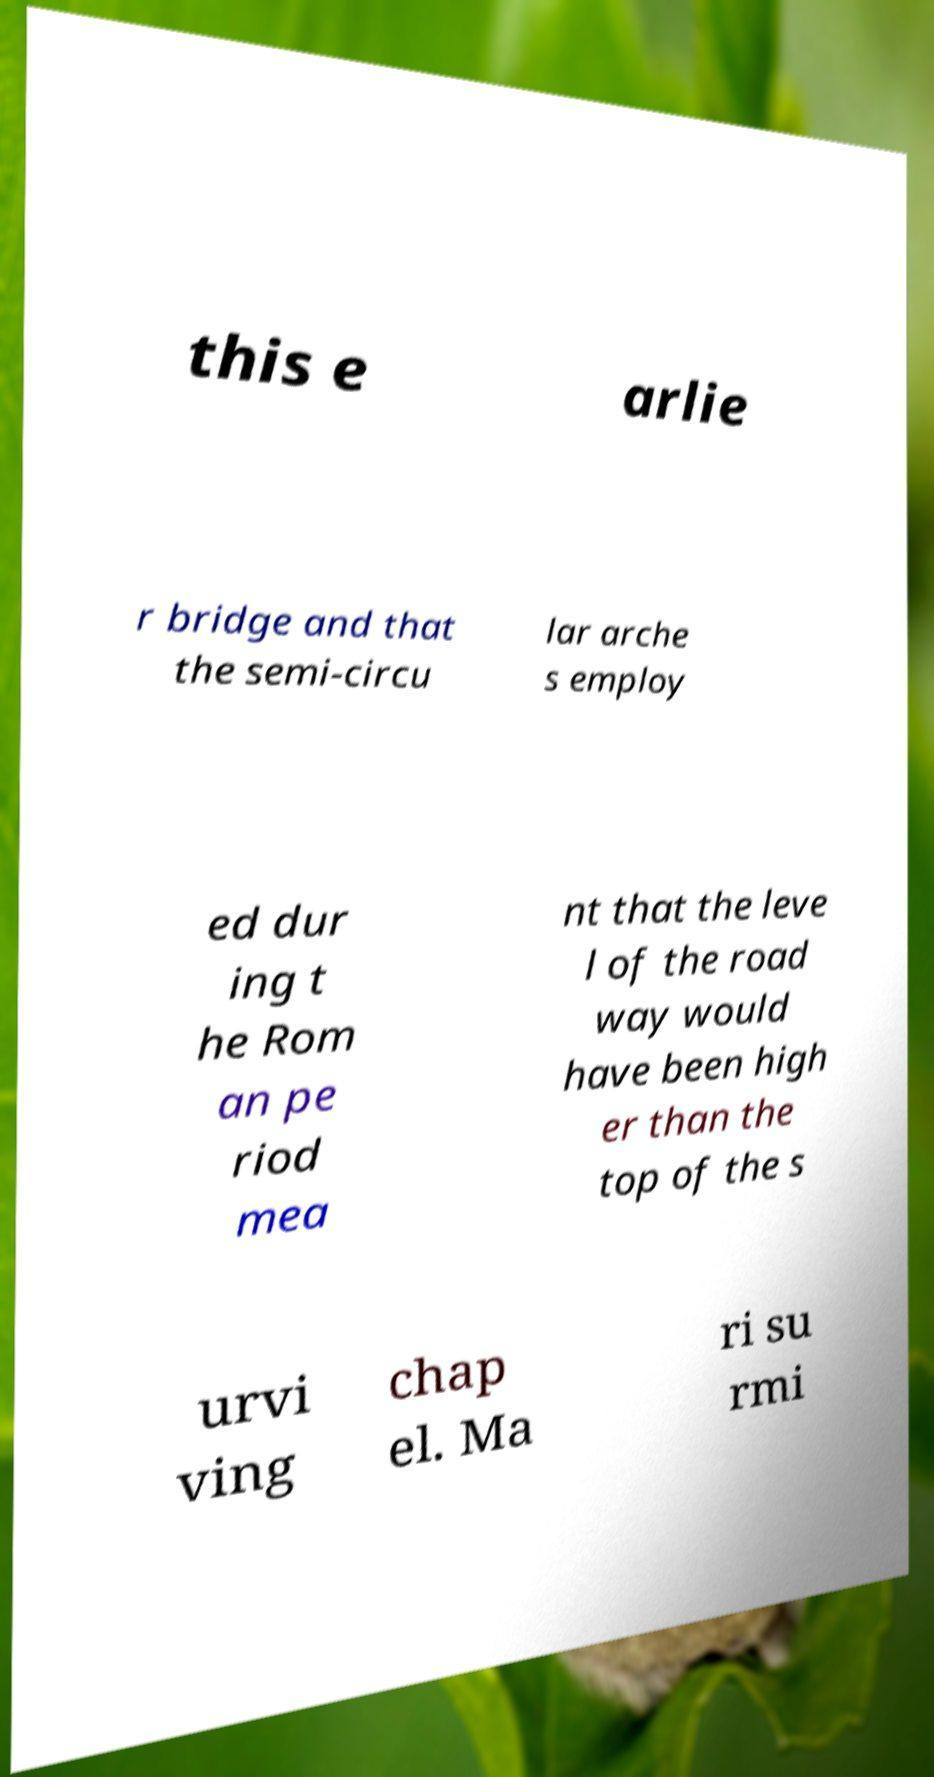Can you read and provide the text displayed in the image?This photo seems to have some interesting text. Can you extract and type it out for me? this e arlie r bridge and that the semi-circu lar arche s employ ed dur ing t he Rom an pe riod mea nt that the leve l of the road way would have been high er than the top of the s urvi ving chap el. Ma ri su rmi 